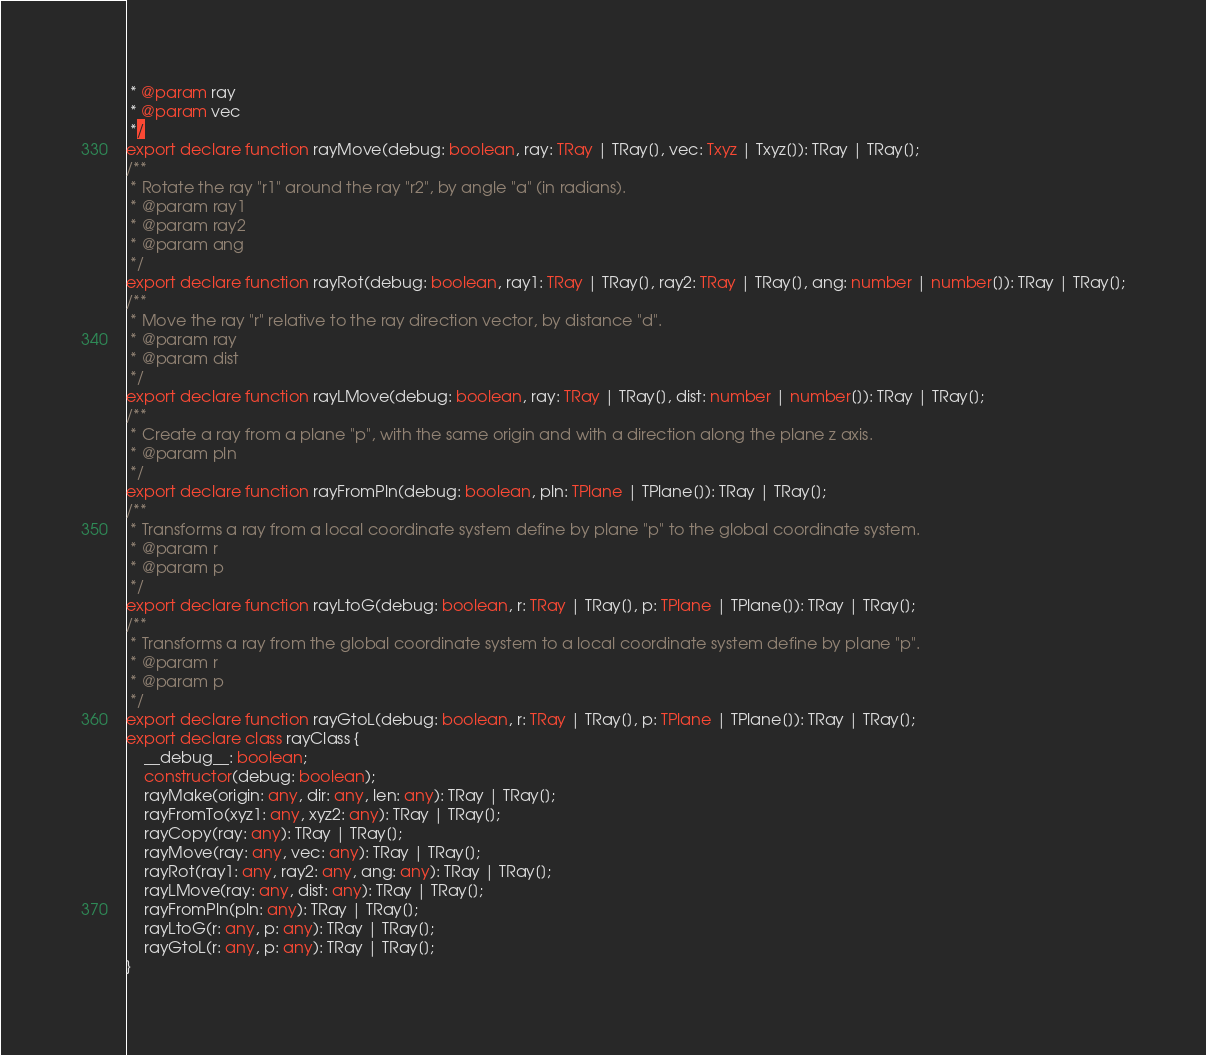<code> <loc_0><loc_0><loc_500><loc_500><_TypeScript_> * @param ray
 * @param vec
 */
export declare function rayMove(debug: boolean, ray: TRay | TRay[], vec: Txyz | Txyz[]): TRay | TRay[];
/**
 * Rotate the ray "r1" around the ray "r2", by angle "a" (in radians).
 * @param ray1
 * @param ray2
 * @param ang
 */
export declare function rayRot(debug: boolean, ray1: TRay | TRay[], ray2: TRay | TRay[], ang: number | number[]): TRay | TRay[];
/**
 * Move the ray "r" relative to the ray direction vector, by distance "d".
 * @param ray
 * @param dist
 */
export declare function rayLMove(debug: boolean, ray: TRay | TRay[], dist: number | number[]): TRay | TRay[];
/**
 * Create a ray from a plane "p", with the same origin and with a direction along the plane z axis.
 * @param pln
 */
export declare function rayFromPln(debug: boolean, pln: TPlane | TPlane[]): TRay | TRay[];
/**
 * Transforms a ray from a local coordinate system define by plane "p" to the global coordinate system.
 * @param r
 * @param p
 */
export declare function rayLtoG(debug: boolean, r: TRay | TRay[], p: TPlane | TPlane[]): TRay | TRay[];
/**
 * Transforms a ray from the global coordinate system to a local coordinate system define by plane "p".
 * @param r
 * @param p
 */
export declare function rayGtoL(debug: boolean, r: TRay | TRay[], p: TPlane | TPlane[]): TRay | TRay[];
export declare class rayClass {
    __debug__: boolean;
    constructor(debug: boolean);
    rayMake(origin: any, dir: any, len: any): TRay | TRay[];
    rayFromTo(xyz1: any, xyz2: any): TRay | TRay[];
    rayCopy(ray: any): TRay | TRay[];
    rayMove(ray: any, vec: any): TRay | TRay[];
    rayRot(ray1: any, ray2: any, ang: any): TRay | TRay[];
    rayLMove(ray: any, dist: any): TRay | TRay[];
    rayFromPln(pln: any): TRay | TRay[];
    rayLtoG(r: any, p: any): TRay | TRay[];
    rayGtoL(r: any, p: any): TRay | TRay[];
}
</code> 